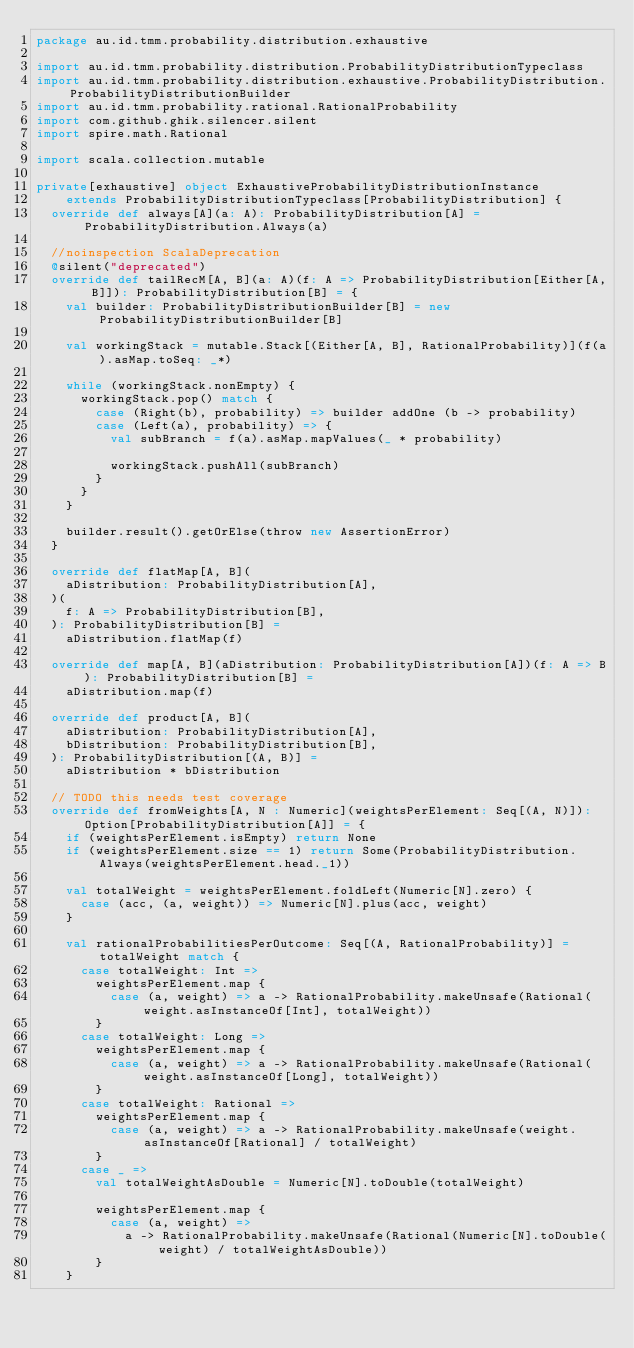<code> <loc_0><loc_0><loc_500><loc_500><_Scala_>package au.id.tmm.probability.distribution.exhaustive

import au.id.tmm.probability.distribution.ProbabilityDistributionTypeclass
import au.id.tmm.probability.distribution.exhaustive.ProbabilityDistribution.ProbabilityDistributionBuilder
import au.id.tmm.probability.rational.RationalProbability
import com.github.ghik.silencer.silent
import spire.math.Rational

import scala.collection.mutable

private[exhaustive] object ExhaustiveProbabilityDistributionInstance
    extends ProbabilityDistributionTypeclass[ProbabilityDistribution] {
  override def always[A](a: A): ProbabilityDistribution[A] = ProbabilityDistribution.Always(a)

  //noinspection ScalaDeprecation
  @silent("deprecated")
  override def tailRecM[A, B](a: A)(f: A => ProbabilityDistribution[Either[A, B]]): ProbabilityDistribution[B] = {
    val builder: ProbabilityDistributionBuilder[B] = new ProbabilityDistributionBuilder[B]

    val workingStack = mutable.Stack[(Either[A, B], RationalProbability)](f(a).asMap.toSeq: _*)

    while (workingStack.nonEmpty) {
      workingStack.pop() match {
        case (Right(b), probability) => builder addOne (b -> probability)
        case (Left(a), probability) => {
          val subBranch = f(a).asMap.mapValues(_ * probability)

          workingStack.pushAll(subBranch)
        }
      }
    }

    builder.result().getOrElse(throw new AssertionError)
  }

  override def flatMap[A, B](
    aDistribution: ProbabilityDistribution[A],
  )(
    f: A => ProbabilityDistribution[B],
  ): ProbabilityDistribution[B] =
    aDistribution.flatMap(f)

  override def map[A, B](aDistribution: ProbabilityDistribution[A])(f: A => B): ProbabilityDistribution[B] =
    aDistribution.map(f)

  override def product[A, B](
    aDistribution: ProbabilityDistribution[A],
    bDistribution: ProbabilityDistribution[B],
  ): ProbabilityDistribution[(A, B)] =
    aDistribution * bDistribution

  // TODO this needs test coverage
  override def fromWeights[A, N : Numeric](weightsPerElement: Seq[(A, N)]): Option[ProbabilityDistribution[A]] = {
    if (weightsPerElement.isEmpty) return None
    if (weightsPerElement.size == 1) return Some(ProbabilityDistribution.Always(weightsPerElement.head._1))

    val totalWeight = weightsPerElement.foldLeft(Numeric[N].zero) {
      case (acc, (a, weight)) => Numeric[N].plus(acc, weight)
    }

    val rationalProbabilitiesPerOutcome: Seq[(A, RationalProbability)] = totalWeight match {
      case totalWeight: Int =>
        weightsPerElement.map {
          case (a, weight) => a -> RationalProbability.makeUnsafe(Rational(weight.asInstanceOf[Int], totalWeight))
        }
      case totalWeight: Long =>
        weightsPerElement.map {
          case (a, weight) => a -> RationalProbability.makeUnsafe(Rational(weight.asInstanceOf[Long], totalWeight))
        }
      case totalWeight: Rational =>
        weightsPerElement.map {
          case (a, weight) => a -> RationalProbability.makeUnsafe(weight.asInstanceOf[Rational] / totalWeight)
        }
      case _ =>
        val totalWeightAsDouble = Numeric[N].toDouble(totalWeight)

        weightsPerElement.map {
          case (a, weight) =>
            a -> RationalProbability.makeUnsafe(Rational(Numeric[N].toDouble(weight) / totalWeightAsDouble))
        }
    }
</code> 